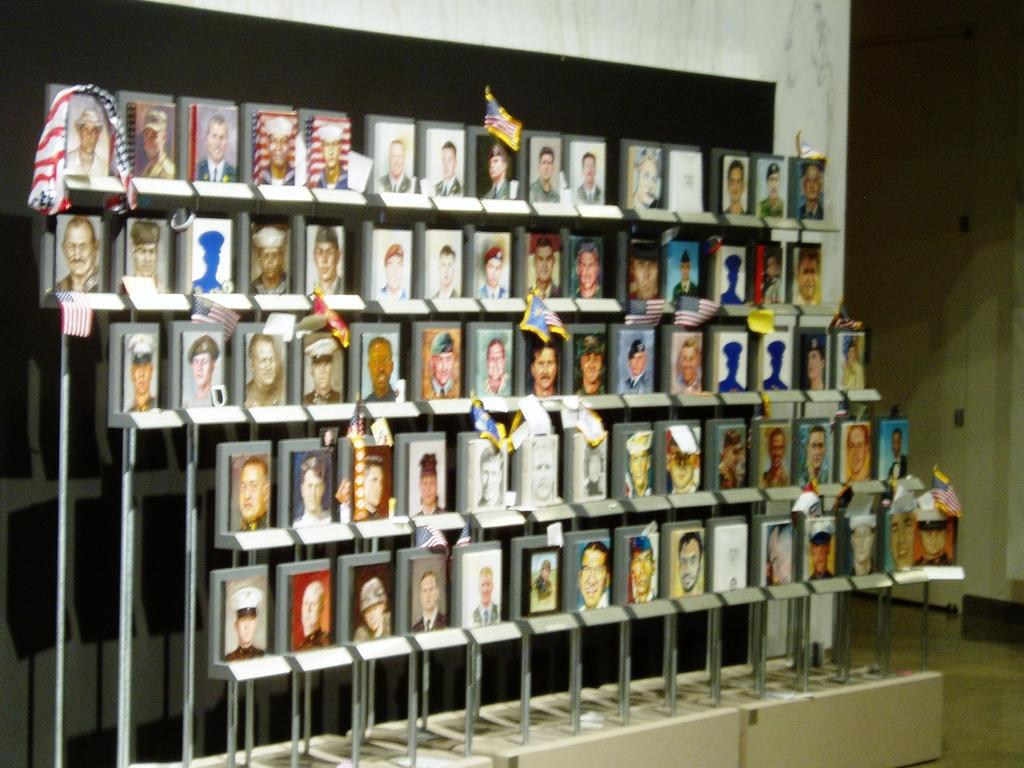What type of structure can be seen in the image? There is a wall in the image. What decorative elements are present on the wall? There are flags in the image. Are there any other objects hanging on the wall? Yes, there are photo frames in the image. How many pigs are visible in the image? There are no pigs present in the image. What type of map is hanging on the wall in the image? There is no map present in the image. 